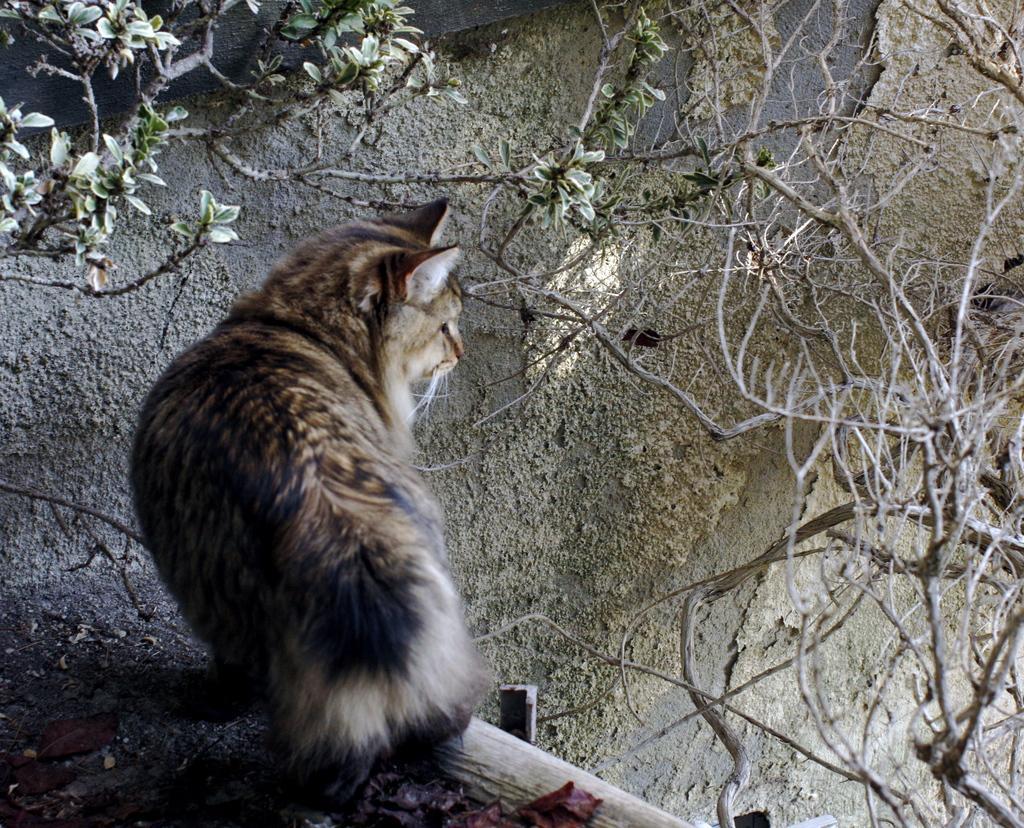In one or two sentences, can you explain what this image depicts? In this image there is a cat standing and staring at something, in front of the cat there is a wall, on the wall there are some dried branches and leaves of a tree. 